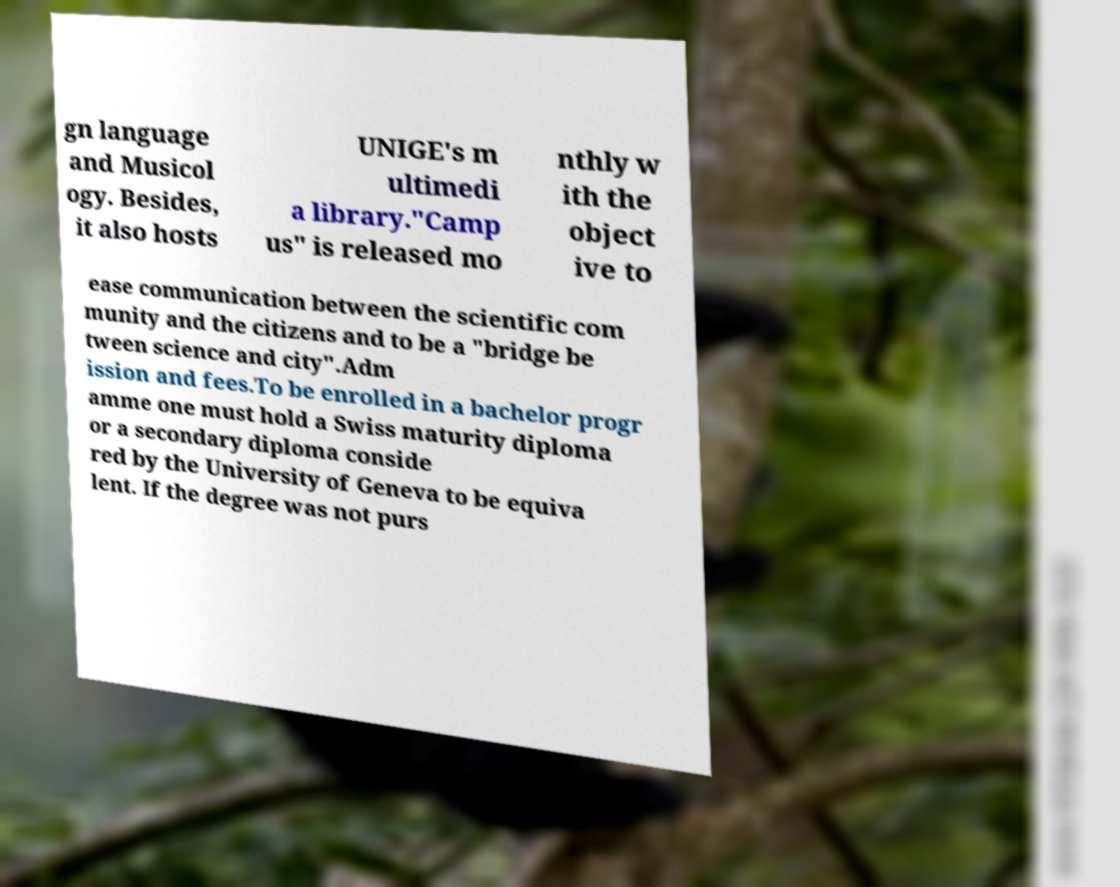Please read and relay the text visible in this image. What does it say? gn language and Musicol ogy. Besides, it also hosts UNIGE's m ultimedi a library."Camp us" is released mo nthly w ith the object ive to ease communication between the scientific com munity and the citizens and to be a "bridge be tween science and city".Adm ission and fees.To be enrolled in a bachelor progr amme one must hold a Swiss maturity diploma or a secondary diploma conside red by the University of Geneva to be equiva lent. If the degree was not purs 